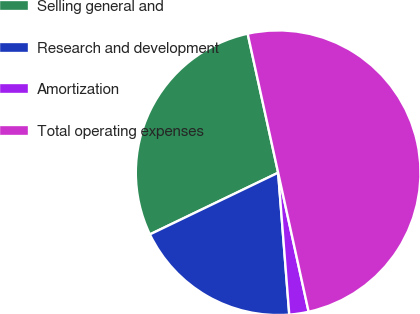Convert chart to OTSL. <chart><loc_0><loc_0><loc_500><loc_500><pie_chart><fcel>Selling general and<fcel>Research and development<fcel>Amortization<fcel>Total operating expenses<nl><fcel>28.7%<fcel>19.11%<fcel>2.19%<fcel>50.0%<nl></chart> 